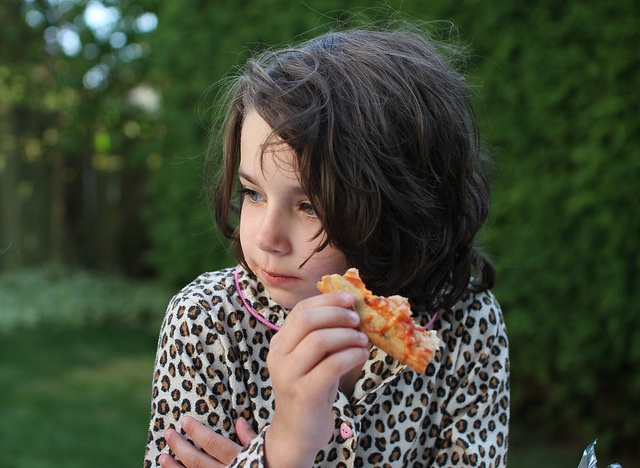Describe the objects in this image and their specific colors. I can see people in darkgreen, black, gray, darkgray, and tan tones and pizza in darkgreen, tan, and brown tones in this image. 